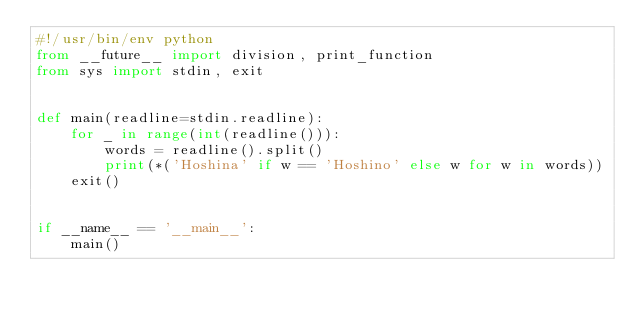Convert code to text. <code><loc_0><loc_0><loc_500><loc_500><_Python_>#!/usr/bin/env python
from __future__ import division, print_function
from sys import stdin, exit


def main(readline=stdin.readline):
    for _ in range(int(readline())):
        words = readline().split()
        print(*('Hoshina' if w == 'Hoshino' else w for w in words))
    exit()


if __name__ == '__main__':
    main()</code> 